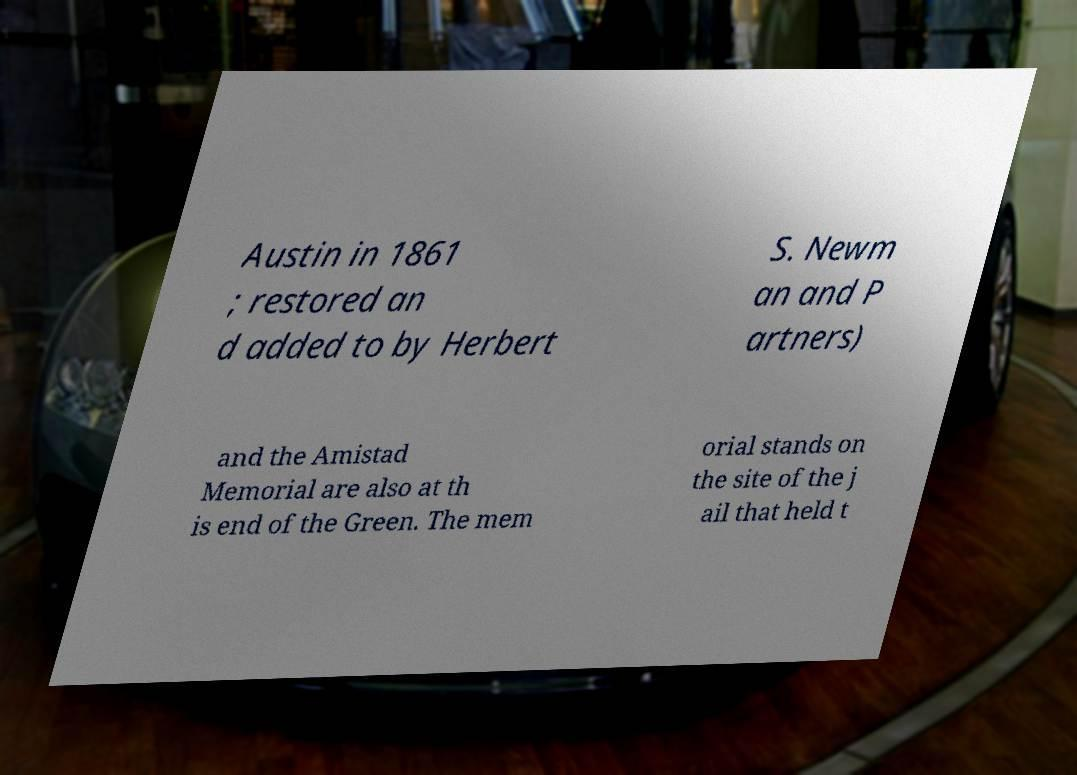Please identify and transcribe the text found in this image. Austin in 1861 ; restored an d added to by Herbert S. Newm an and P artners) and the Amistad Memorial are also at th is end of the Green. The mem orial stands on the site of the j ail that held t 